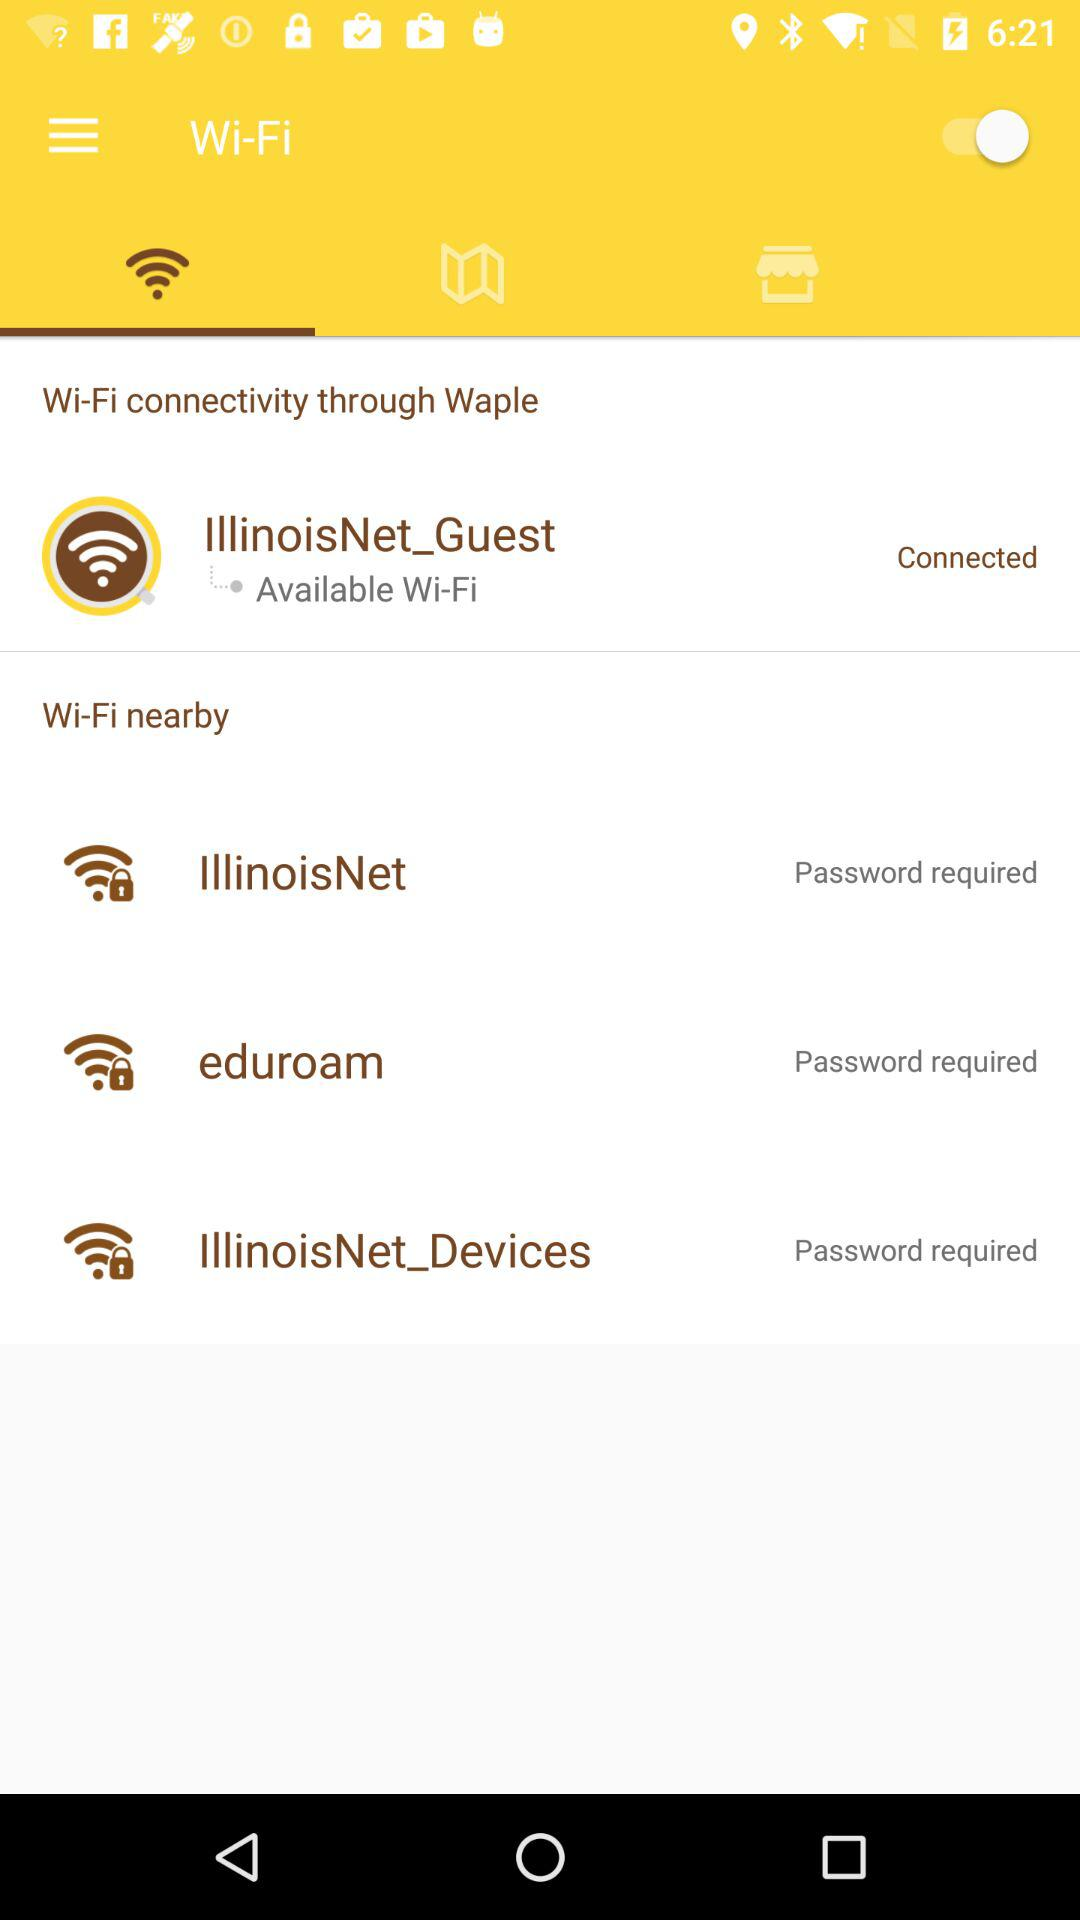What is the name of the connected Wi-Fi? The name of the connected Wi-Fi is "IllinoisNet_Guest". 